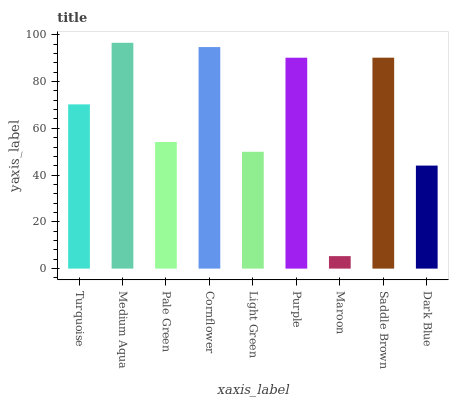Is Maroon the minimum?
Answer yes or no. Yes. Is Medium Aqua the maximum?
Answer yes or no. Yes. Is Pale Green the minimum?
Answer yes or no. No. Is Pale Green the maximum?
Answer yes or no. No. Is Medium Aqua greater than Pale Green?
Answer yes or no. Yes. Is Pale Green less than Medium Aqua?
Answer yes or no. Yes. Is Pale Green greater than Medium Aqua?
Answer yes or no. No. Is Medium Aqua less than Pale Green?
Answer yes or no. No. Is Turquoise the high median?
Answer yes or no. Yes. Is Turquoise the low median?
Answer yes or no. Yes. Is Medium Aqua the high median?
Answer yes or no. No. Is Medium Aqua the low median?
Answer yes or no. No. 